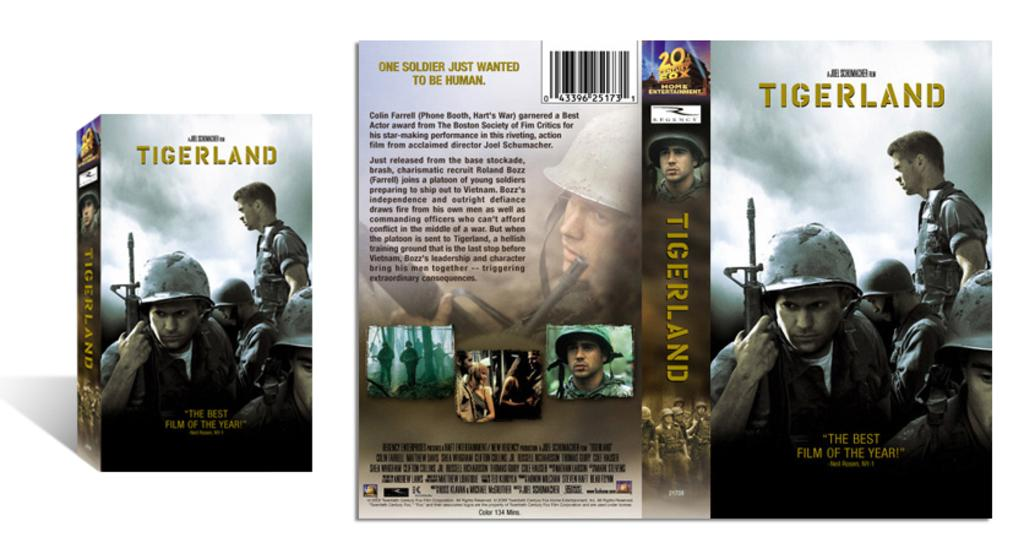<image>
Describe the image concisely. A box of a movie called Tigerland which is considered as the best film of the year. 